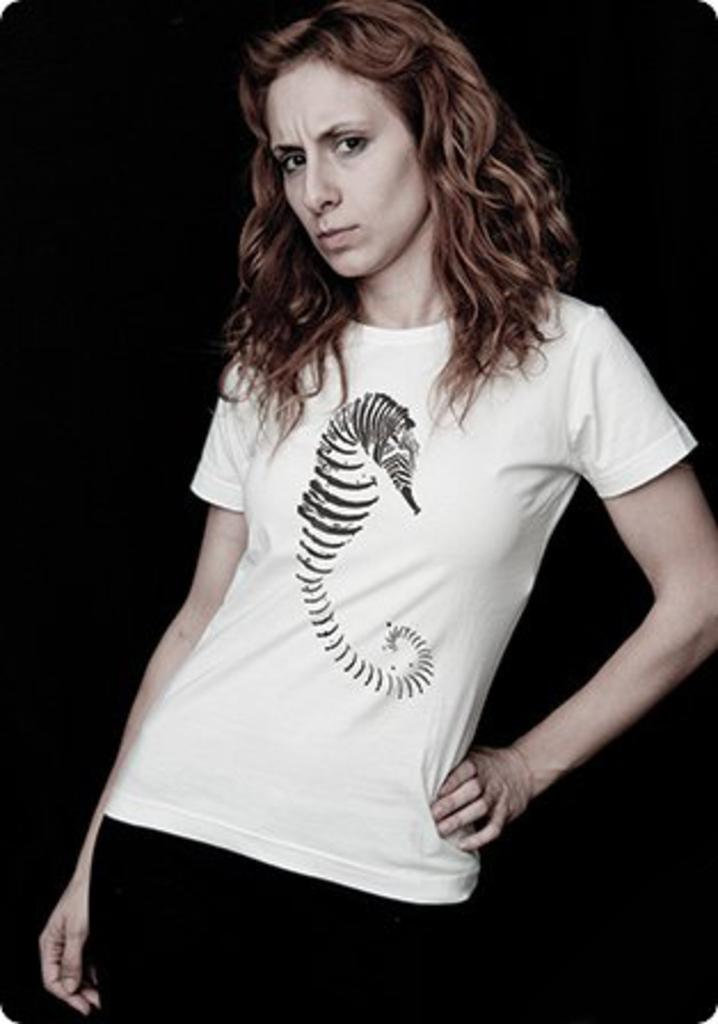What is the main subject of the image? There is a photograph of a woman in the image. What is the woman doing in the image? The woman is standing in the image. How is the woman posing in the image? The woman has her hand on her hip in the image. What is the woman wearing in the image? The woman is wearing a white T-shirt in the image. What design is on the woman's T-shirt? The T-shirt has an eel drawing on it. What is the color of the woman's hair? The woman has brown hair in the image. How many rods can be seen in the image? There are no rods present in the image; it features a photograph of a woman. What type of hydrant is visible in the background of the image? There is no hydrant visible in the image; it only contains a photograph of a woman. 